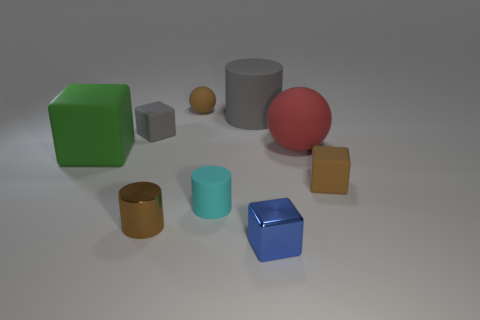What size is the gray thing that is the same shape as the cyan matte thing?
Give a very brief answer. Large. What number of cylinders are either red rubber things or brown metallic objects?
Give a very brief answer. 1. What number of tiny matte things are in front of the tiny rubber block that is behind the tiny brown object that is on the right side of the small blue thing?
Your answer should be compact. 2. The rubber thing that is the same color as the big matte cylinder is what size?
Your answer should be very brief. Small. Are there any other objects that have the same material as the small cyan thing?
Your response must be concise. Yes. Are the blue block and the brown sphere made of the same material?
Make the answer very short. No. How many gray things are left of the gray matte cylinder that is on the left side of the brown rubber cube?
Your answer should be compact. 1. What number of yellow things are either tiny metal objects or spheres?
Your response must be concise. 0. What shape is the brown rubber object that is in front of the red ball that is in front of the tiny rubber block that is behind the big block?
Your answer should be compact. Cube. What color is the rubber cylinder that is the same size as the brown block?
Keep it short and to the point. Cyan. 